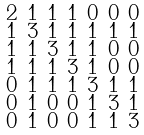Convert formula to latex. <formula><loc_0><loc_0><loc_500><loc_500>\begin{smallmatrix} 2 & 1 & 1 & 1 & 0 & 0 & 0 \\ 1 & 3 & 1 & 1 & 1 & 1 & 1 \\ 1 & 1 & 3 & 1 & 1 & 0 & 0 \\ 1 & 1 & 1 & 3 & 1 & 0 & 0 \\ 0 & 1 & 1 & 1 & 3 & 1 & 1 \\ 0 & 1 & 0 & 0 & 1 & 3 & 1 \\ 0 & 1 & 0 & 0 & 1 & 1 & 3 \end{smallmatrix}</formula> 